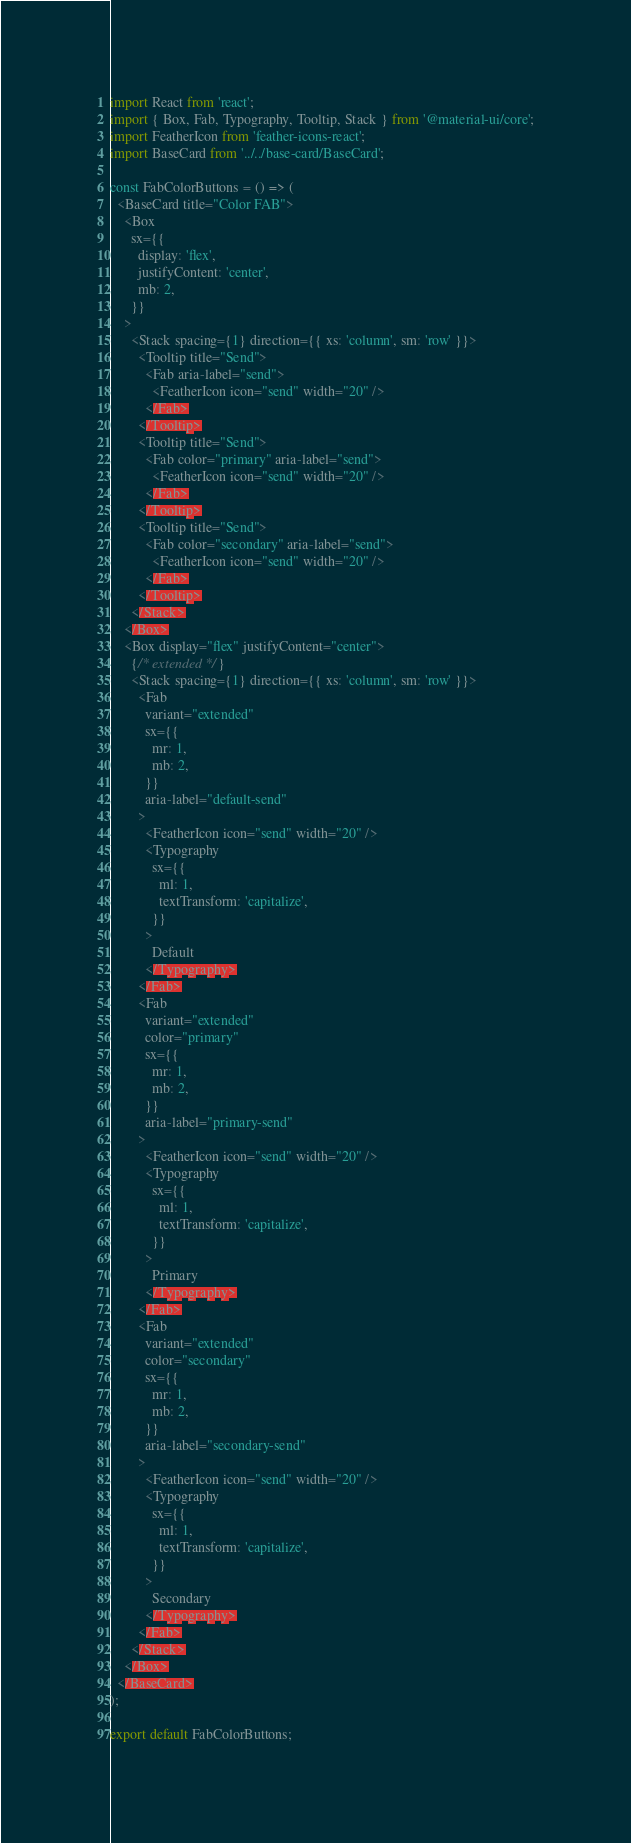<code> <loc_0><loc_0><loc_500><loc_500><_JavaScript_>import React from 'react';
import { Box, Fab, Typography, Tooltip, Stack } from '@material-ui/core';
import FeatherIcon from 'feather-icons-react';
import BaseCard from '../../base-card/BaseCard';

const FabColorButtons = () => (
  <BaseCard title="Color FAB">
    <Box
      sx={{
        display: 'flex',
        justifyContent: 'center',
        mb: 2,
      }}
    >
      <Stack spacing={1} direction={{ xs: 'column', sm: 'row' }}>
        <Tooltip title="Send">
          <Fab aria-label="send">
            <FeatherIcon icon="send" width="20" />
          </Fab>
        </Tooltip>
        <Tooltip title="Send">
          <Fab color="primary" aria-label="send">
            <FeatherIcon icon="send" width="20" />
          </Fab>
        </Tooltip>
        <Tooltip title="Send">
          <Fab color="secondary" aria-label="send">
            <FeatherIcon icon="send" width="20" />
          </Fab>
        </Tooltip>
      </Stack>
    </Box>
    <Box display="flex" justifyContent="center">
      {/* extended */}
      <Stack spacing={1} direction={{ xs: 'column', sm: 'row' }}>
        <Fab
          variant="extended"
          sx={{
            mr: 1,
            mb: 2,
          }}
          aria-label="default-send"
        >
          <FeatherIcon icon="send" width="20" />
          <Typography
            sx={{
              ml: 1,
              textTransform: 'capitalize',
            }}
          >
            Default
          </Typography>
        </Fab>
        <Fab
          variant="extended"
          color="primary"
          sx={{
            mr: 1,
            mb: 2,
          }}
          aria-label="primary-send"
        >
          <FeatherIcon icon="send" width="20" />
          <Typography
            sx={{
              ml: 1,
              textTransform: 'capitalize',
            }}
          >
            Primary
          </Typography>
        </Fab>
        <Fab
          variant="extended"
          color="secondary"
          sx={{
            mr: 1,
            mb: 2,
          }}
          aria-label="secondary-send"
        >
          <FeatherIcon icon="send" width="20" />
          <Typography
            sx={{
              ml: 1,
              textTransform: 'capitalize',
            }}
          >
            Secondary
          </Typography>
        </Fab>
      </Stack>
    </Box>
  </BaseCard>
);

export default FabColorButtons;
</code> 